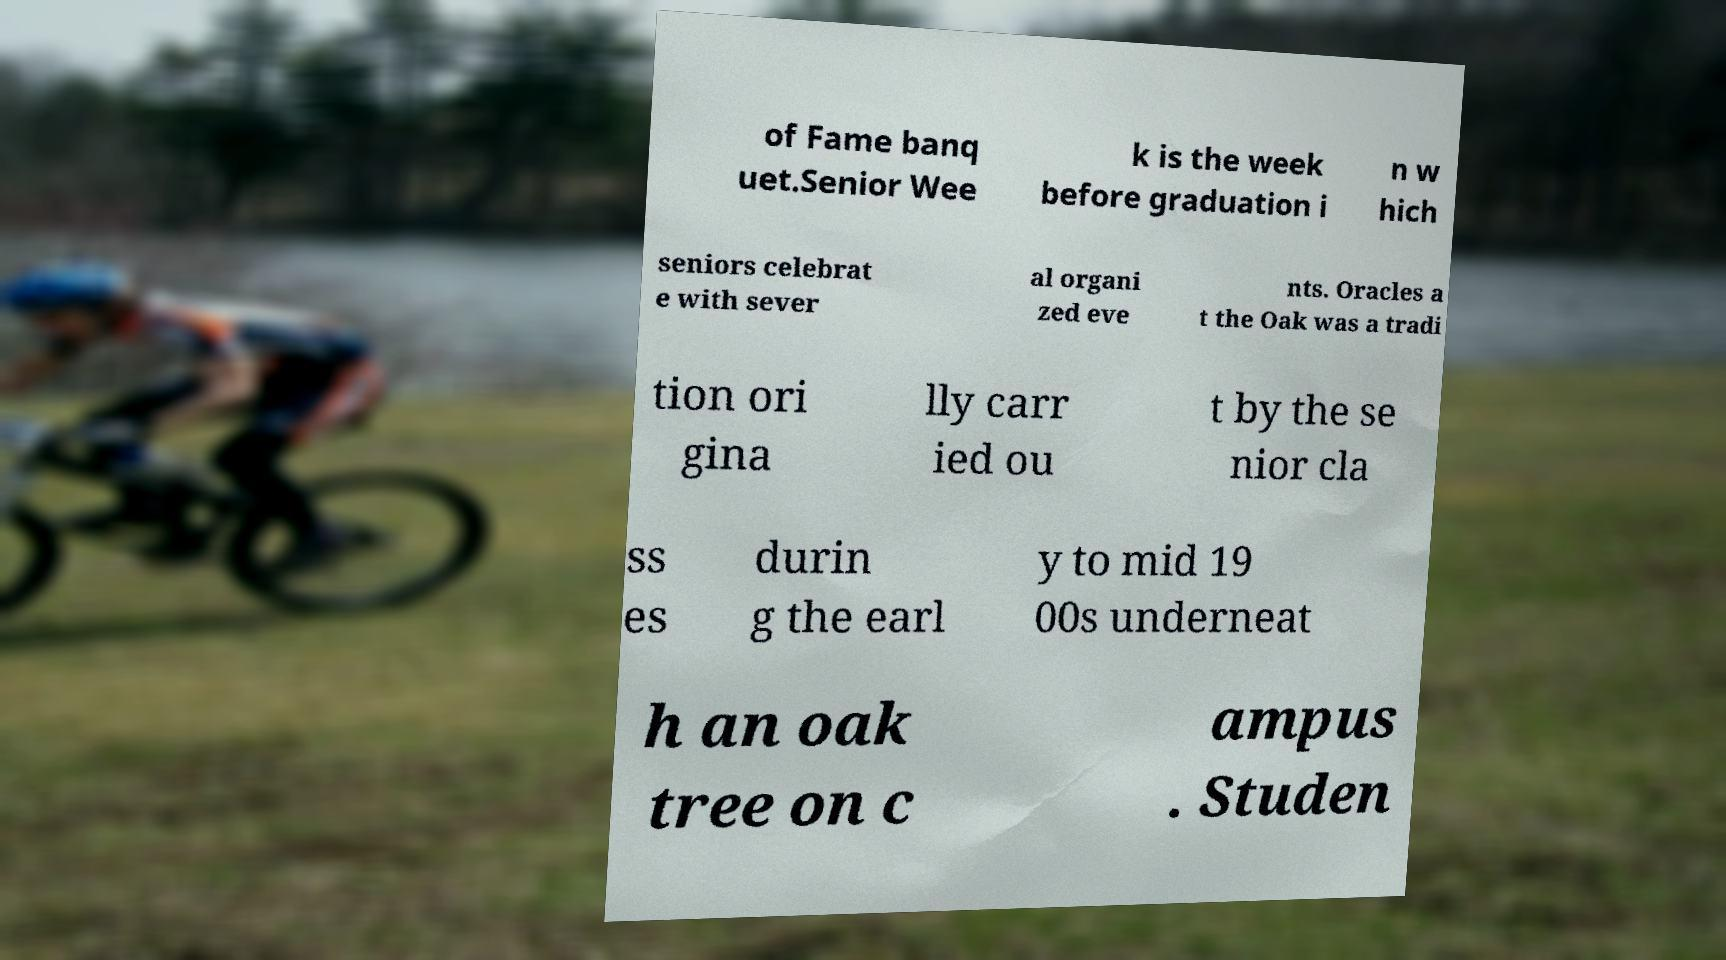Could you assist in decoding the text presented in this image and type it out clearly? of Fame banq uet.Senior Wee k is the week before graduation i n w hich seniors celebrat e with sever al organi zed eve nts. Oracles a t the Oak was a tradi tion ori gina lly carr ied ou t by the se nior cla ss es durin g the earl y to mid 19 00s underneat h an oak tree on c ampus . Studen 